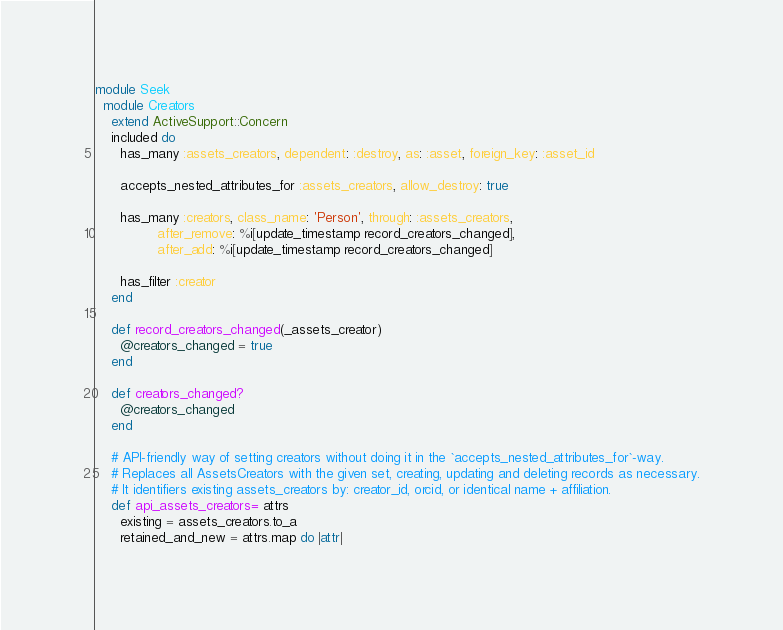<code> <loc_0><loc_0><loc_500><loc_500><_Ruby_>module Seek
  module Creators
    extend ActiveSupport::Concern
    included do
      has_many :assets_creators, dependent: :destroy, as: :asset, foreign_key: :asset_id

      accepts_nested_attributes_for :assets_creators, allow_destroy: true

      has_many :creators, class_name: 'Person', through: :assets_creators,
               after_remove: %i[update_timestamp record_creators_changed],
               after_add: %i[update_timestamp record_creators_changed]

      has_filter :creator
    end

    def record_creators_changed(_assets_creator)
      @creators_changed = true
    end

    def creators_changed?
      @creators_changed
    end

    # API-friendly way of setting creators without doing it in the `accepts_nested_attributes_for`-way.
    # Replaces all AssetsCreators with the given set, creating, updating and deleting records as necessary.
    # It identifiers existing assets_creators by: creator_id, orcid, or identical name + affiliation.
    def api_assets_creators= attrs
      existing = assets_creators.to_a
      retained_and_new = attrs.map do |attr|</code> 